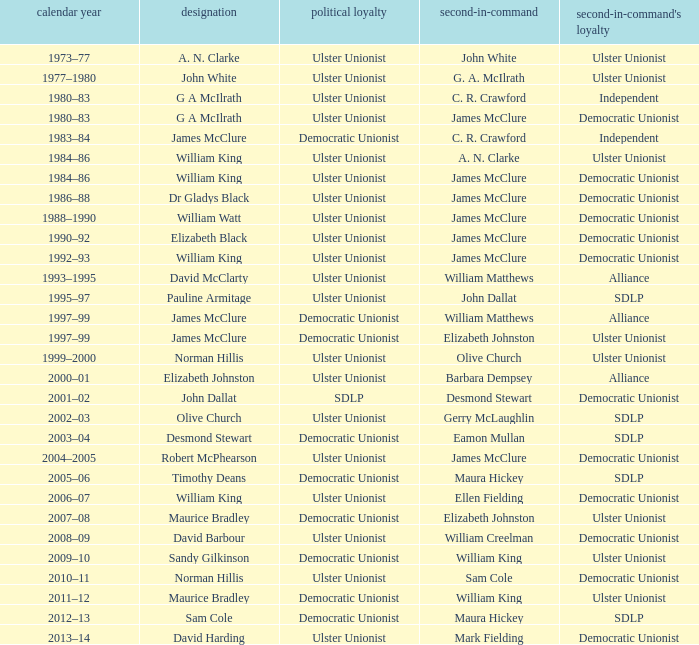What is the Political affiliation of deputy john dallat? Ulster Unionist. 